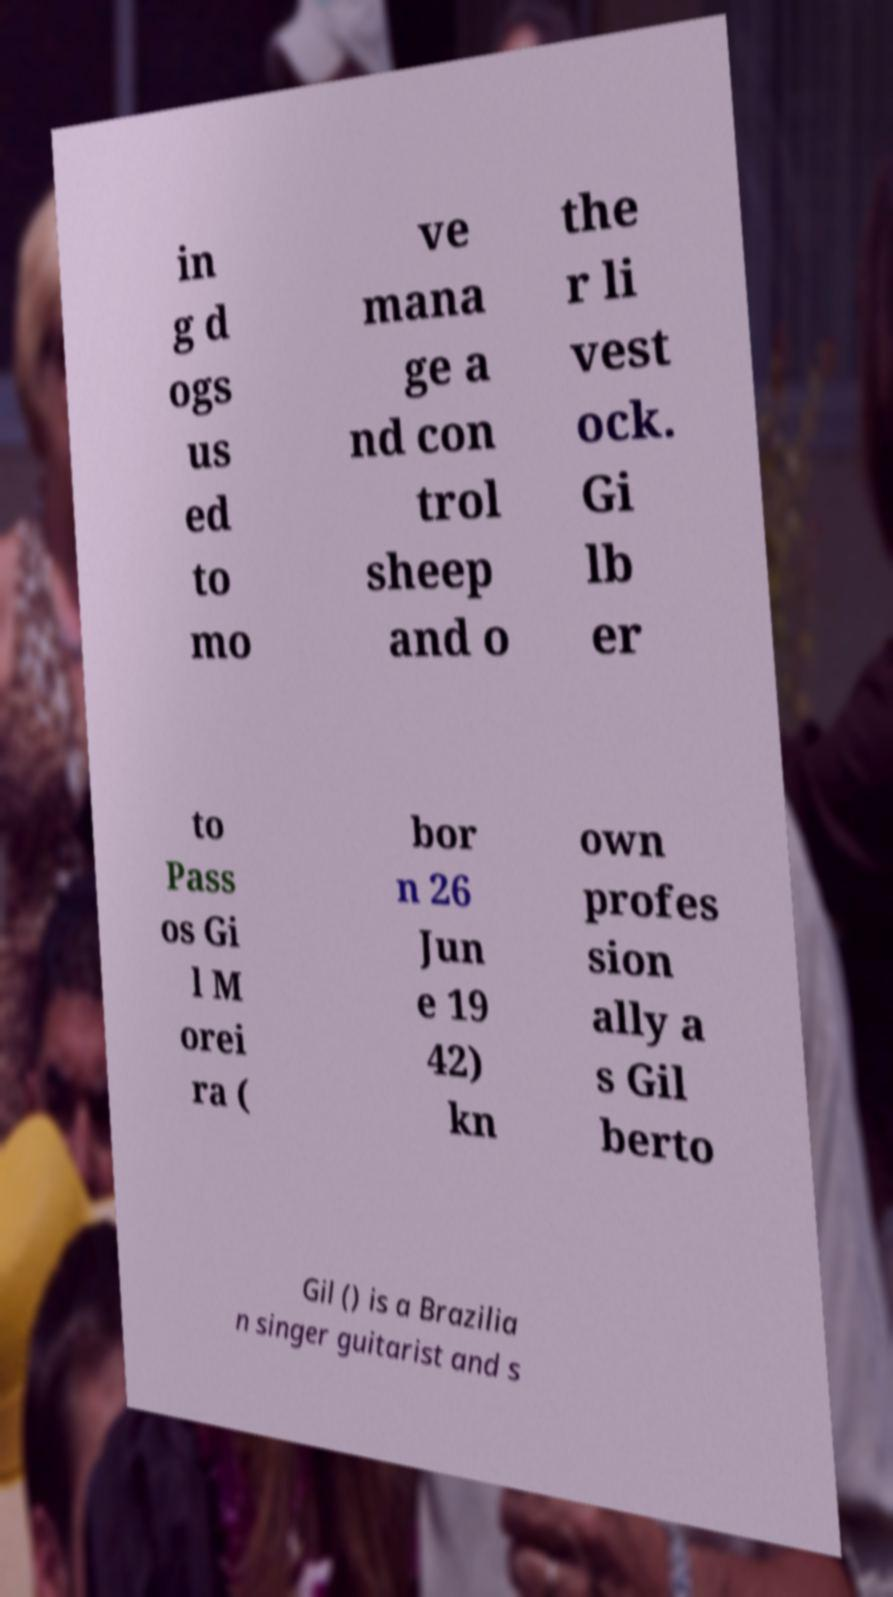Could you assist in decoding the text presented in this image and type it out clearly? in g d ogs us ed to mo ve mana ge a nd con trol sheep and o the r li vest ock. Gi lb er to Pass os Gi l M orei ra ( bor n 26 Jun e 19 42) kn own profes sion ally a s Gil berto Gil () is a Brazilia n singer guitarist and s 